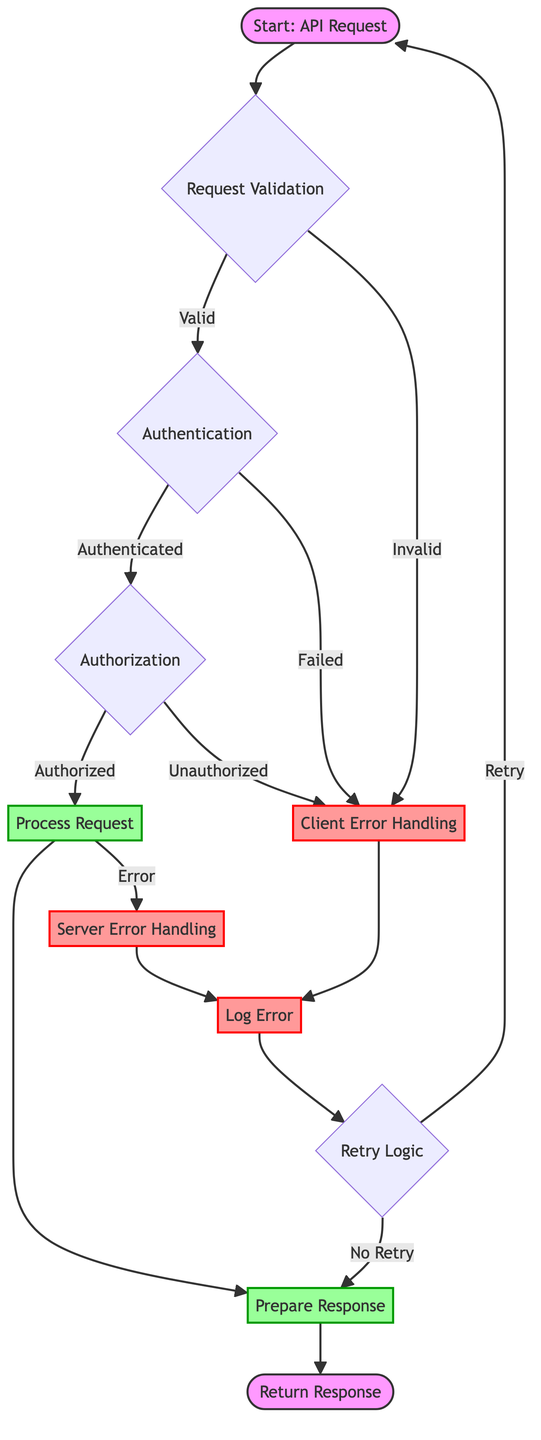What is the first step in the flow? The flow starts with the "Start: API Request" node, which is the first element in the diagram indicating the action of sending an HTTP request to the specified RESTful API endpoint.
Answer: Start: API Request How many error handling nodes are present? There are two error handling nodes: "Client Error Handling" and "Server Error Handling," which deal with different types of errors that may occur during the API call process.
Answer: 2 What happens if the request validation fails? If the "Request Validation" fails, the flow directs toward the "Client Error Handling" node, indicating that the request has issues that need to be addressed from the client's side.
Answer: Client Error Handling What does "Authentication" check for? The "Authentication" node checks whether the API call has valid authentication credentials, such as API keys or OAuth tokens, which are necessary for a secure connection.
Answer: Valid authentication credentials What follows after "Process Request" if there is an error? If there is an error during the "Process Request," the flow directs to the "Server Error Handling" node, indicating that a server-side issue has occurred.
Answer: Server Error Handling What are the two outcomes from the "Retry Logic"? The "Retry Logic" can lead to either a "Retry," which loops back to the "Start: API Request," or "No Retry," which continues to the "Prepare Response" node for returning the result.
Answer: Retry or No Retry How does the flow handle unauthorized requests? When an unauthorized request is identified at the "Authorization" stage, the flow leads to the "Client Error Handling" node, indicating that the user does not have permission for the requested operation.
Answer: Client Error Handling In the case of an error, where is the error logged? The "Log Error" node indicates the step in the flow where error details are documented for troubleshooting and analytics upon detecting an error.
Answer: Log Error What is created after processing the request? After the "Process Request," the flow leads to "Prepare Response," which creates an appropriate response based on the outcome of the API call including success or error messages.
Answer: Prepare Response 